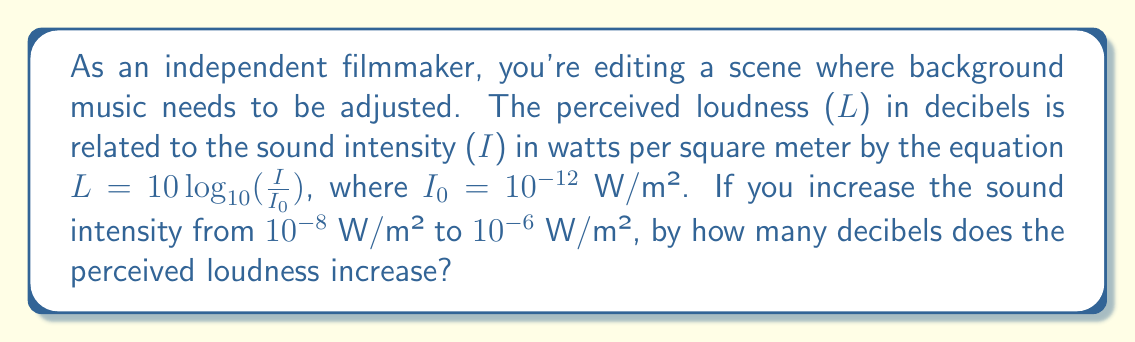Provide a solution to this math problem. Let's approach this step-by-step:

1) We need to calculate the difference in perceived loudness (L) for two different intensities.

2) For the initial intensity $I_1 = 10^{-8}$ W/m²:
   $L_1 = 10 \log_{10}(\frac{10^{-8}}{10^{-12}}) = 10 \log_{10}(10^4) = 10 \cdot 4 = 40$ dB

3) For the final intensity $I_2 = 10^{-6}$ W/m²:
   $L_2 = 10 \log_{10}(\frac{10^{-6}}{10^{-12}}) = 10 \log_{10}(10^6) = 10 \cdot 6 = 60$ dB

4) The increase in perceived loudness is the difference between these two values:
   $\Delta L = L_2 - L_1 = 60 - 40 = 20$ dB

5) We can verify this using the properties of logarithms:
   $\Delta L = 10 \log_{10}(\frac{I_2}{I_1}) = 10 \log_{10}(\frac{10^{-6}}{10^{-8}}) = 10 \log_{10}(10^2) = 20$ dB

Therefore, the perceived loudness increases by 20 decibels.
Answer: 20 dB 